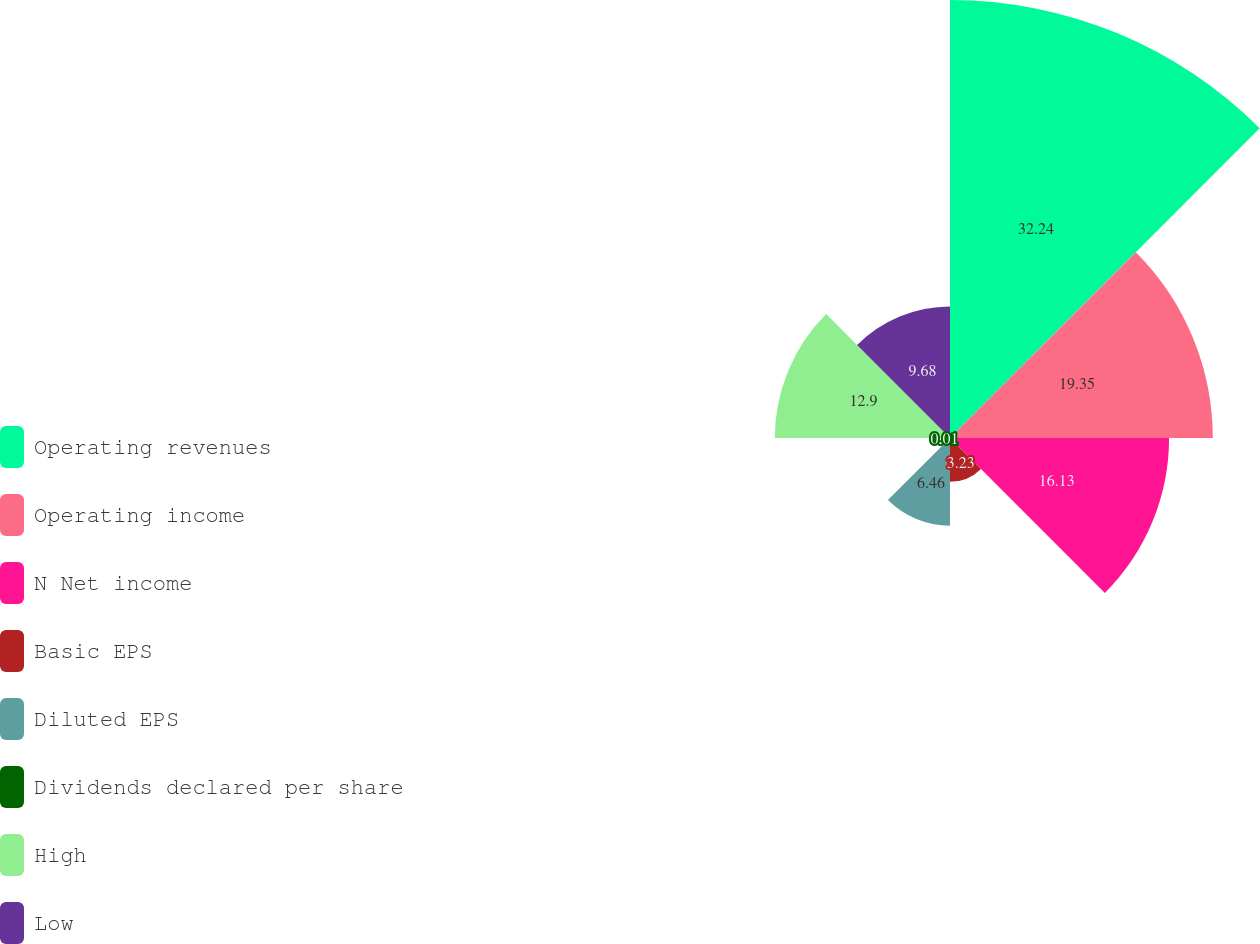Convert chart. <chart><loc_0><loc_0><loc_500><loc_500><pie_chart><fcel>Operating revenues<fcel>Operating income<fcel>N Net income<fcel>Basic EPS<fcel>Diluted EPS<fcel>Dividends declared per share<fcel>High<fcel>Low<nl><fcel>32.25%<fcel>19.35%<fcel>16.13%<fcel>3.23%<fcel>6.46%<fcel>0.01%<fcel>12.9%<fcel>9.68%<nl></chart> 